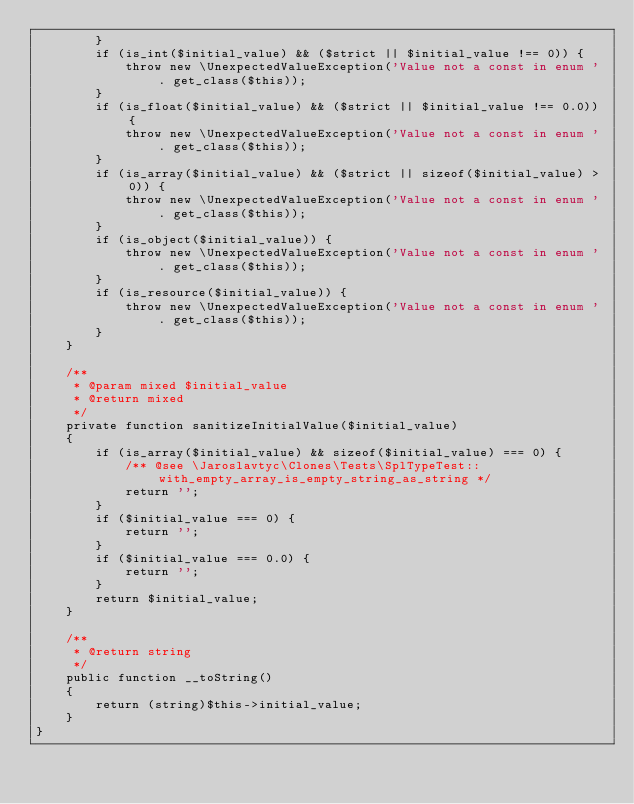Convert code to text. <code><loc_0><loc_0><loc_500><loc_500><_PHP_>        }
        if (is_int($initial_value) && ($strict || $initial_value !== 0)) {
            throw new \UnexpectedValueException('Value not a const in enum ' . get_class($this));
        }
        if (is_float($initial_value) && ($strict || $initial_value !== 0.0)) {
            throw new \UnexpectedValueException('Value not a const in enum ' . get_class($this));
        }
        if (is_array($initial_value) && ($strict || sizeof($initial_value) > 0)) {
            throw new \UnexpectedValueException('Value not a const in enum ' . get_class($this));
        }
        if (is_object($initial_value)) {
            throw new \UnexpectedValueException('Value not a const in enum ' . get_class($this));
        }
        if (is_resource($initial_value)) {
            throw new \UnexpectedValueException('Value not a const in enum ' . get_class($this));
        }
    }

    /**
     * @param mixed $initial_value
     * @return mixed
     */
    private function sanitizeInitialValue($initial_value)
    {
        if (is_array($initial_value) && sizeof($initial_value) === 0) {
            /** @see \Jaroslavtyc\Clones\Tests\SplTypeTest::with_empty_array_is_empty_string_as_string */
            return '';
        }
        if ($initial_value === 0) {
            return '';
        }
        if ($initial_value === 0.0) {
            return '';
        }
        return $initial_value;
    }

    /**
     * @return string
     */
    public function __toString()
    {
        return (string)$this->initial_value;
    }
}
</code> 